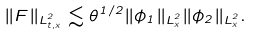Convert formula to latex. <formula><loc_0><loc_0><loc_500><loc_500>\| F \| _ { L ^ { 2 } _ { t , x } } \lesssim \theta ^ { 1 / 2 } \| \phi _ { 1 } \| _ { L ^ { 2 } _ { x } } \| \phi _ { 2 } \| _ { L ^ { 2 } _ { x } } .</formula> 